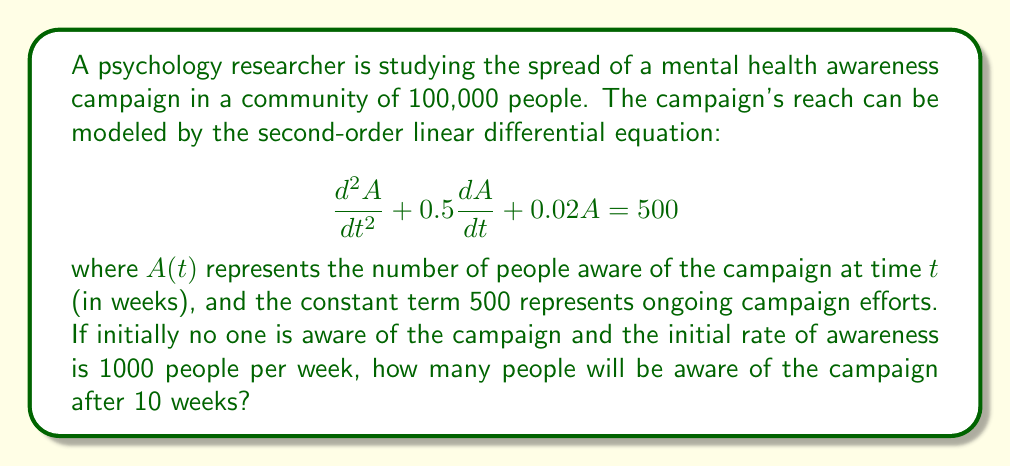Show me your answer to this math problem. To solve this problem, we need to follow these steps:

1) First, we identify the initial conditions:
   $A(0) = 0$ (no one is initially aware)
   $A'(0) = 1000$ (initial rate of awareness)

2) The general solution to this second-order linear differential equation is:
   $$A(t) = A_h(t) + A_p(t)$$
   where $A_h(t)$ is the homogeneous solution and $A_p(t)$ is the particular solution.

3) For the homogeneous part, we solve the characteristic equation:
   $$r^2 + 0.5r + 0.02 = 0$$
   Using the quadratic formula, we get:
   $$r = \frac{-0.5 \pm \sqrt{0.5^2 - 4(0.02)}}{2} = -0.25 \pm 0.0968$$

4) Therefore, the homogeneous solution is:
   $$A_h(t) = c_1e^{(-0.25+0.0968)t} + c_2e^{(-0.25-0.0968)t}$$

5) For the particular solution, since the right side is constant, we assume:
   $$A_p(t) = k$$
   Substituting this into the original equation:
   $$0 + 0 + 0.02k = 500$$
   $$k = 25000$$

6) The general solution is thus:
   $$A(t) = c_1e^{-0.1532t} + c_2e^{-0.3468t} + 25000$$

7) Using the initial conditions:
   $A(0) = 0$:  $c_1 + c_2 + 25000 = 0$
   $A'(0) = 1000$: $-0.1532c_1 - 0.3468c_2 = 1000$

8) Solving this system of equations:
   $c_1 \approx -33950.62$
   $c_2 \approx 8950.62$

9) Therefore, the specific solution is:
   $$A(t) = -33950.62e^{-0.1532t} + 8950.62e^{-0.3468t} + 25000$$

10) To find $A(10)$, we substitute $t=10$:
    $$A(10) = -33950.62e^{-1.532} + 8950.62e^{-3.468} + 25000$$
Answer: $A(10) \approx 18,331$

After 10 weeks, approximately 18,331 people will be aware of the mental health campaign. 